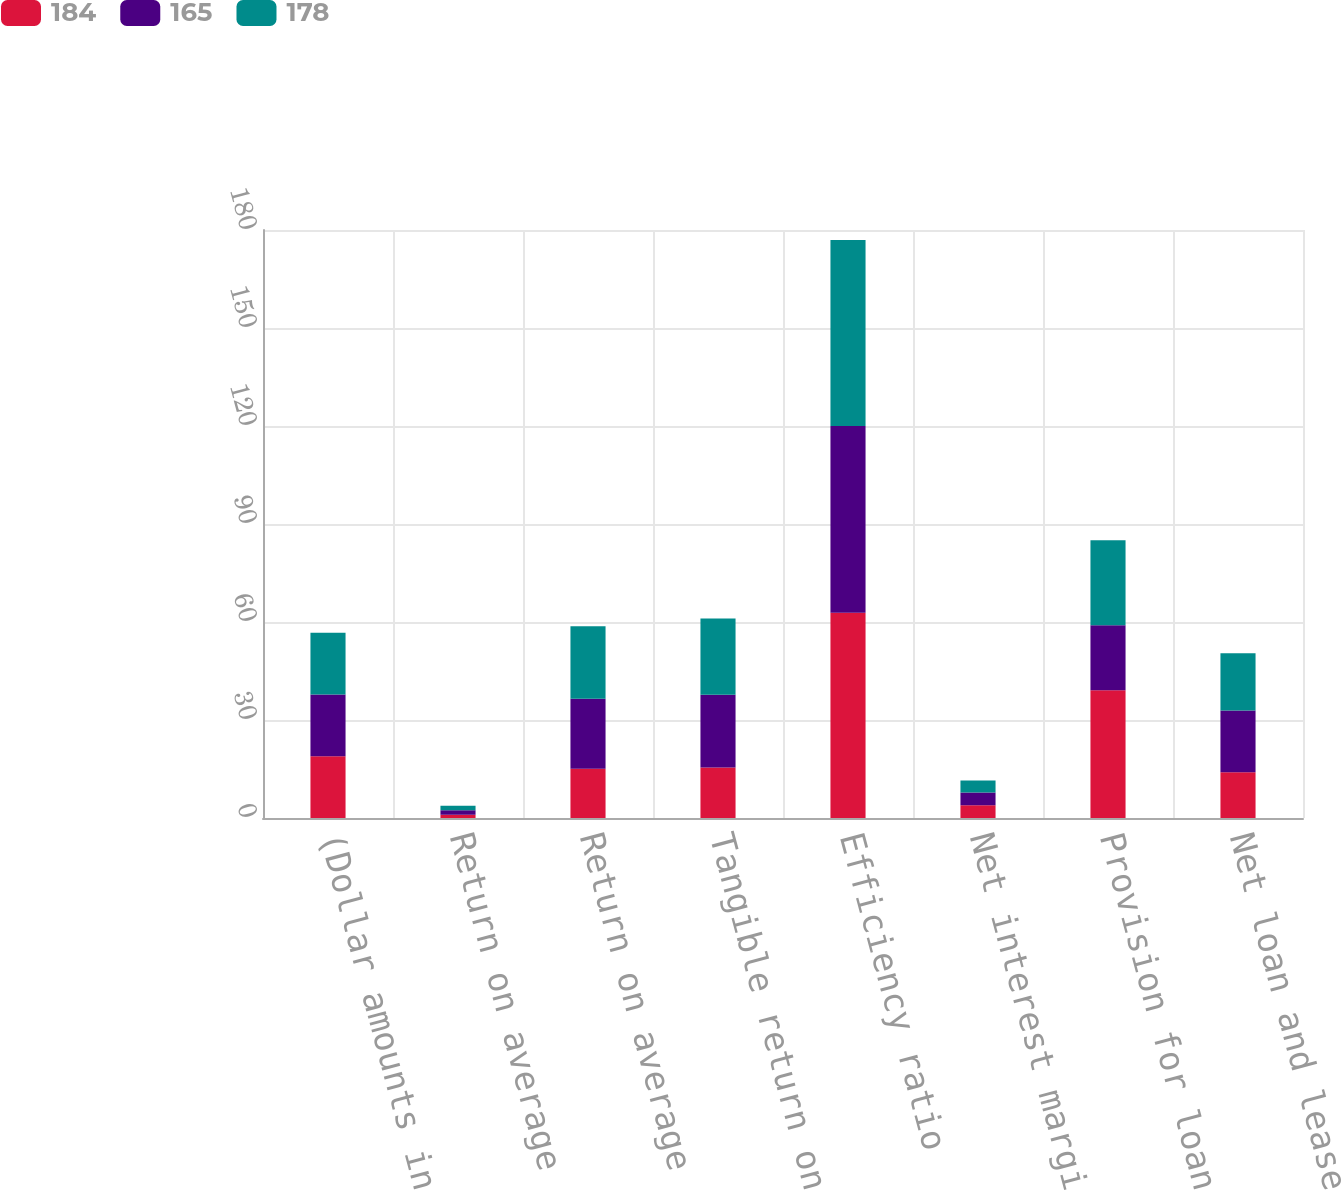Convert chart to OTSL. <chart><loc_0><loc_0><loc_500><loc_500><stacked_bar_chart><ecel><fcel>(Dollar amounts in millions)<fcel>Return on average assets<fcel>Return on average common<fcel>Tangible return on average<fcel>Efficiency ratio<fcel>Net interest margin<fcel>Provision for loan losses<fcel>Net loan and lease charge-offs<nl><fcel>184<fcel>18.9<fcel>0.98<fcel>15.04<fcel>15.49<fcel>62.82<fcel>3.9<fcel>39.1<fcel>14<nl><fcel>165<fcel>18.9<fcel>1.39<fcel>21.47<fcel>22.27<fcel>57.15<fcel>3.89<fcel>19.9<fcel>18.9<nl><fcel>178<fcel>18.9<fcel>1.4<fcel>22.22<fcel>23.32<fcel>56.95<fcel>3.68<fcel>26<fcel>17.5<nl></chart> 